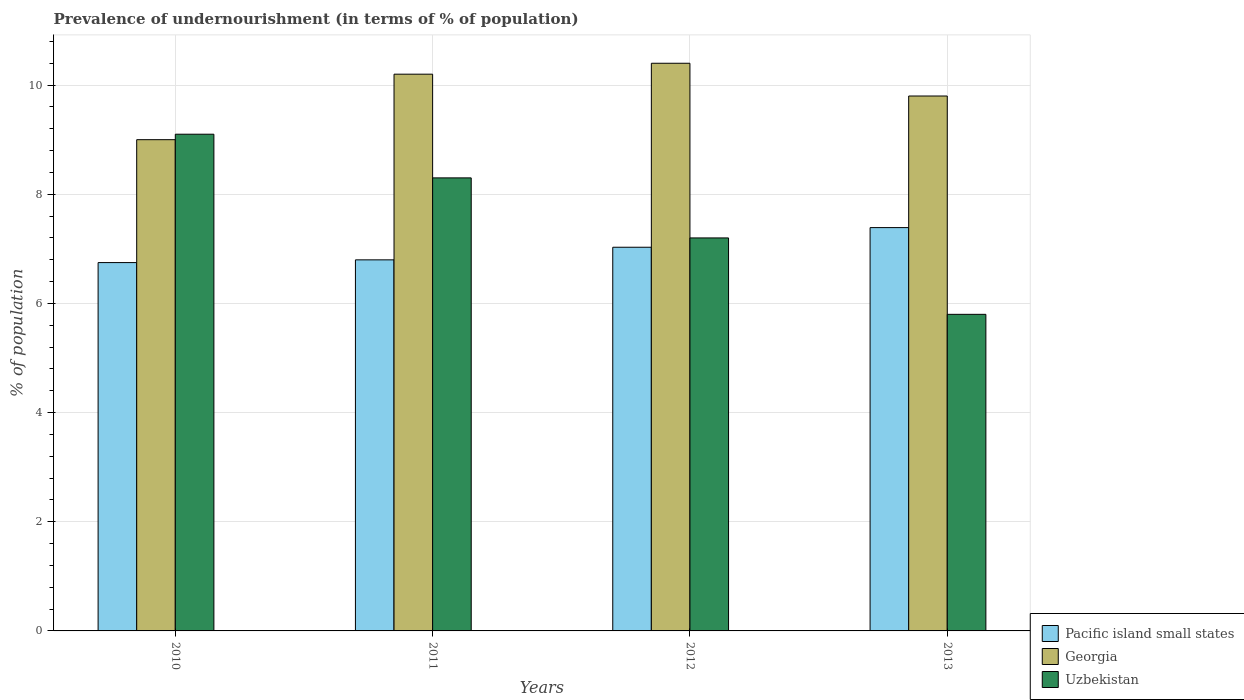How many different coloured bars are there?
Provide a short and direct response. 3. Are the number of bars on each tick of the X-axis equal?
Your answer should be very brief. Yes. How many bars are there on the 3rd tick from the left?
Provide a succinct answer. 3. What is the label of the 2nd group of bars from the left?
Your answer should be compact. 2011. Across all years, what is the maximum percentage of undernourished population in Georgia?
Offer a very short reply. 10.4. What is the total percentage of undernourished population in Uzbekistan in the graph?
Give a very brief answer. 30.4. What is the difference between the percentage of undernourished population in Pacific island small states in 2010 and that in 2012?
Offer a terse response. -0.28. What is the difference between the percentage of undernourished population in Georgia in 2012 and the percentage of undernourished population in Uzbekistan in 2013?
Your response must be concise. 4.6. What is the average percentage of undernourished population in Georgia per year?
Provide a short and direct response. 9.85. In the year 2010, what is the difference between the percentage of undernourished population in Pacific island small states and percentage of undernourished population in Uzbekistan?
Provide a short and direct response. -2.35. In how many years, is the percentage of undernourished population in Pacific island small states greater than 10 %?
Your answer should be compact. 0. What is the ratio of the percentage of undernourished population in Georgia in 2011 to that in 2013?
Your response must be concise. 1.04. Is the difference between the percentage of undernourished population in Pacific island small states in 2010 and 2013 greater than the difference between the percentage of undernourished population in Uzbekistan in 2010 and 2013?
Provide a succinct answer. No. What is the difference between the highest and the second highest percentage of undernourished population in Pacific island small states?
Offer a very short reply. 0.36. What is the difference between the highest and the lowest percentage of undernourished population in Georgia?
Ensure brevity in your answer.  1.4. In how many years, is the percentage of undernourished population in Uzbekistan greater than the average percentage of undernourished population in Uzbekistan taken over all years?
Keep it short and to the point. 2. What does the 2nd bar from the left in 2013 represents?
Make the answer very short. Georgia. What does the 2nd bar from the right in 2010 represents?
Provide a succinct answer. Georgia. Are all the bars in the graph horizontal?
Give a very brief answer. No. What is the difference between two consecutive major ticks on the Y-axis?
Offer a terse response. 2. Are the values on the major ticks of Y-axis written in scientific E-notation?
Your response must be concise. No. Does the graph contain any zero values?
Make the answer very short. No. Does the graph contain grids?
Offer a terse response. Yes. Where does the legend appear in the graph?
Provide a succinct answer. Bottom right. What is the title of the graph?
Offer a terse response. Prevalence of undernourishment (in terms of % of population). What is the label or title of the X-axis?
Offer a very short reply. Years. What is the label or title of the Y-axis?
Your answer should be compact. % of population. What is the % of population in Pacific island small states in 2010?
Make the answer very short. 6.75. What is the % of population of Uzbekistan in 2010?
Your answer should be very brief. 9.1. What is the % of population of Pacific island small states in 2011?
Ensure brevity in your answer.  6.8. What is the % of population of Pacific island small states in 2012?
Give a very brief answer. 7.03. What is the % of population in Uzbekistan in 2012?
Your answer should be very brief. 7.2. What is the % of population in Pacific island small states in 2013?
Offer a terse response. 7.39. What is the % of population of Georgia in 2013?
Your answer should be compact. 9.8. What is the % of population in Uzbekistan in 2013?
Offer a terse response. 5.8. Across all years, what is the maximum % of population in Pacific island small states?
Provide a succinct answer. 7.39. Across all years, what is the maximum % of population of Georgia?
Offer a very short reply. 10.4. Across all years, what is the minimum % of population in Pacific island small states?
Your answer should be very brief. 6.75. Across all years, what is the minimum % of population of Georgia?
Your response must be concise. 9. Across all years, what is the minimum % of population in Uzbekistan?
Offer a very short reply. 5.8. What is the total % of population of Pacific island small states in the graph?
Provide a succinct answer. 27.96. What is the total % of population of Georgia in the graph?
Provide a short and direct response. 39.4. What is the total % of population of Uzbekistan in the graph?
Ensure brevity in your answer.  30.4. What is the difference between the % of population in Pacific island small states in 2010 and that in 2011?
Provide a short and direct response. -0.05. What is the difference between the % of population of Uzbekistan in 2010 and that in 2011?
Keep it short and to the point. 0.8. What is the difference between the % of population of Pacific island small states in 2010 and that in 2012?
Your answer should be very brief. -0.28. What is the difference between the % of population in Pacific island small states in 2010 and that in 2013?
Keep it short and to the point. -0.64. What is the difference between the % of population in Georgia in 2010 and that in 2013?
Make the answer very short. -0.8. What is the difference between the % of population in Pacific island small states in 2011 and that in 2012?
Provide a succinct answer. -0.23. What is the difference between the % of population in Pacific island small states in 2011 and that in 2013?
Offer a terse response. -0.59. What is the difference between the % of population of Georgia in 2011 and that in 2013?
Provide a short and direct response. 0.4. What is the difference between the % of population of Uzbekistan in 2011 and that in 2013?
Make the answer very short. 2.5. What is the difference between the % of population of Pacific island small states in 2012 and that in 2013?
Give a very brief answer. -0.36. What is the difference between the % of population in Georgia in 2012 and that in 2013?
Provide a short and direct response. 0.6. What is the difference between the % of population of Uzbekistan in 2012 and that in 2013?
Provide a short and direct response. 1.4. What is the difference between the % of population of Pacific island small states in 2010 and the % of population of Georgia in 2011?
Offer a very short reply. -3.45. What is the difference between the % of population of Pacific island small states in 2010 and the % of population of Uzbekistan in 2011?
Provide a succinct answer. -1.55. What is the difference between the % of population of Georgia in 2010 and the % of population of Uzbekistan in 2011?
Your response must be concise. 0.7. What is the difference between the % of population in Pacific island small states in 2010 and the % of population in Georgia in 2012?
Provide a succinct answer. -3.65. What is the difference between the % of population of Pacific island small states in 2010 and the % of population of Uzbekistan in 2012?
Offer a very short reply. -0.45. What is the difference between the % of population of Pacific island small states in 2010 and the % of population of Georgia in 2013?
Your response must be concise. -3.05. What is the difference between the % of population of Pacific island small states in 2010 and the % of population of Uzbekistan in 2013?
Your response must be concise. 0.95. What is the difference between the % of population in Pacific island small states in 2011 and the % of population in Georgia in 2012?
Make the answer very short. -3.6. What is the difference between the % of population of Pacific island small states in 2011 and the % of population of Uzbekistan in 2012?
Keep it short and to the point. -0.4. What is the difference between the % of population in Georgia in 2011 and the % of population in Uzbekistan in 2012?
Your answer should be very brief. 3. What is the difference between the % of population of Pacific island small states in 2011 and the % of population of Georgia in 2013?
Ensure brevity in your answer.  -3. What is the difference between the % of population in Pacific island small states in 2011 and the % of population in Uzbekistan in 2013?
Your answer should be compact. 1. What is the difference between the % of population of Pacific island small states in 2012 and the % of population of Georgia in 2013?
Ensure brevity in your answer.  -2.77. What is the difference between the % of population in Pacific island small states in 2012 and the % of population in Uzbekistan in 2013?
Make the answer very short. 1.23. What is the average % of population of Pacific island small states per year?
Offer a very short reply. 6.99. What is the average % of population in Georgia per year?
Your answer should be very brief. 9.85. In the year 2010, what is the difference between the % of population in Pacific island small states and % of population in Georgia?
Provide a succinct answer. -2.25. In the year 2010, what is the difference between the % of population in Pacific island small states and % of population in Uzbekistan?
Provide a short and direct response. -2.35. In the year 2010, what is the difference between the % of population in Georgia and % of population in Uzbekistan?
Ensure brevity in your answer.  -0.1. In the year 2011, what is the difference between the % of population in Pacific island small states and % of population in Georgia?
Your answer should be compact. -3.4. In the year 2011, what is the difference between the % of population in Pacific island small states and % of population in Uzbekistan?
Ensure brevity in your answer.  -1.5. In the year 2011, what is the difference between the % of population in Georgia and % of population in Uzbekistan?
Your answer should be compact. 1.9. In the year 2012, what is the difference between the % of population in Pacific island small states and % of population in Georgia?
Ensure brevity in your answer.  -3.37. In the year 2012, what is the difference between the % of population in Pacific island small states and % of population in Uzbekistan?
Provide a short and direct response. -0.17. In the year 2013, what is the difference between the % of population in Pacific island small states and % of population in Georgia?
Your answer should be compact. -2.41. In the year 2013, what is the difference between the % of population of Pacific island small states and % of population of Uzbekistan?
Your answer should be compact. 1.59. What is the ratio of the % of population of Pacific island small states in 2010 to that in 2011?
Your response must be concise. 0.99. What is the ratio of the % of population in Georgia in 2010 to that in 2011?
Provide a succinct answer. 0.88. What is the ratio of the % of population of Uzbekistan in 2010 to that in 2011?
Offer a very short reply. 1.1. What is the ratio of the % of population of Pacific island small states in 2010 to that in 2012?
Your answer should be compact. 0.96. What is the ratio of the % of population of Georgia in 2010 to that in 2012?
Offer a terse response. 0.87. What is the ratio of the % of population in Uzbekistan in 2010 to that in 2012?
Provide a succinct answer. 1.26. What is the ratio of the % of population of Pacific island small states in 2010 to that in 2013?
Give a very brief answer. 0.91. What is the ratio of the % of population of Georgia in 2010 to that in 2013?
Your response must be concise. 0.92. What is the ratio of the % of population of Uzbekistan in 2010 to that in 2013?
Your response must be concise. 1.57. What is the ratio of the % of population of Pacific island small states in 2011 to that in 2012?
Your response must be concise. 0.97. What is the ratio of the % of population in Georgia in 2011 to that in 2012?
Your answer should be compact. 0.98. What is the ratio of the % of population in Uzbekistan in 2011 to that in 2012?
Your answer should be very brief. 1.15. What is the ratio of the % of population in Georgia in 2011 to that in 2013?
Make the answer very short. 1.04. What is the ratio of the % of population of Uzbekistan in 2011 to that in 2013?
Your answer should be very brief. 1.43. What is the ratio of the % of population of Pacific island small states in 2012 to that in 2013?
Give a very brief answer. 0.95. What is the ratio of the % of population of Georgia in 2012 to that in 2013?
Offer a terse response. 1.06. What is the ratio of the % of population of Uzbekistan in 2012 to that in 2013?
Your answer should be very brief. 1.24. What is the difference between the highest and the second highest % of population in Pacific island small states?
Provide a short and direct response. 0.36. What is the difference between the highest and the second highest % of population of Uzbekistan?
Give a very brief answer. 0.8. What is the difference between the highest and the lowest % of population of Pacific island small states?
Your response must be concise. 0.64. 